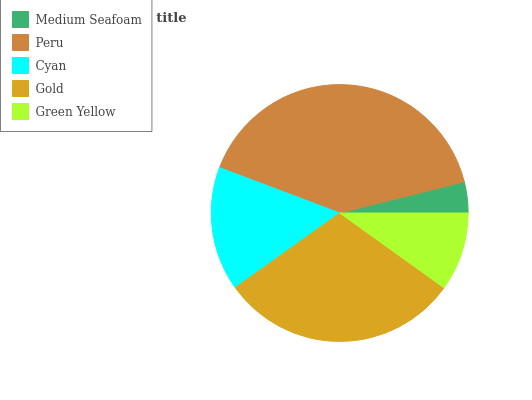Is Medium Seafoam the minimum?
Answer yes or no. Yes. Is Peru the maximum?
Answer yes or no. Yes. Is Cyan the minimum?
Answer yes or no. No. Is Cyan the maximum?
Answer yes or no. No. Is Peru greater than Cyan?
Answer yes or no. Yes. Is Cyan less than Peru?
Answer yes or no. Yes. Is Cyan greater than Peru?
Answer yes or no. No. Is Peru less than Cyan?
Answer yes or no. No. Is Cyan the high median?
Answer yes or no. Yes. Is Cyan the low median?
Answer yes or no. Yes. Is Green Yellow the high median?
Answer yes or no. No. Is Green Yellow the low median?
Answer yes or no. No. 